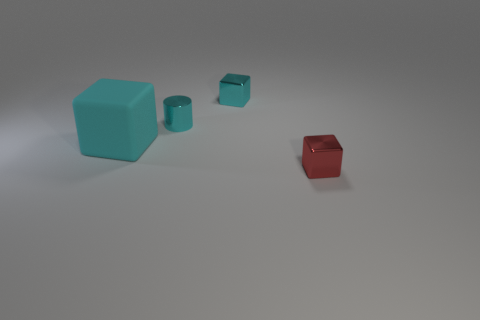There is a cyan object that is the same material as the small cyan block; what is its shape?
Offer a very short reply. Cylinder. Is the color of the metallic cylinder the same as the small block that is behind the large cyan rubber object?
Give a very brief answer. Yes. The cyan block that is made of the same material as the small red cube is what size?
Your answer should be very brief. Small. Are there any cylinders that have the same color as the big matte thing?
Offer a terse response. Yes. What number of objects are either cyan objects that are in front of the small shiny cylinder or cyan shiny cubes?
Keep it short and to the point. 2. Do the cylinder and the small object in front of the large cyan matte cube have the same material?
Offer a very short reply. Yes. The metallic cube that is the same color as the small cylinder is what size?
Your answer should be very brief. Small. Are there any small blue cylinders that have the same material as the tiny cyan block?
Offer a terse response. No. How many things are either metal blocks that are in front of the matte object or small cubes in front of the tiny cylinder?
Provide a succinct answer. 1. Does the big cyan rubber thing have the same shape as the thing that is in front of the cyan matte object?
Your response must be concise. Yes. 